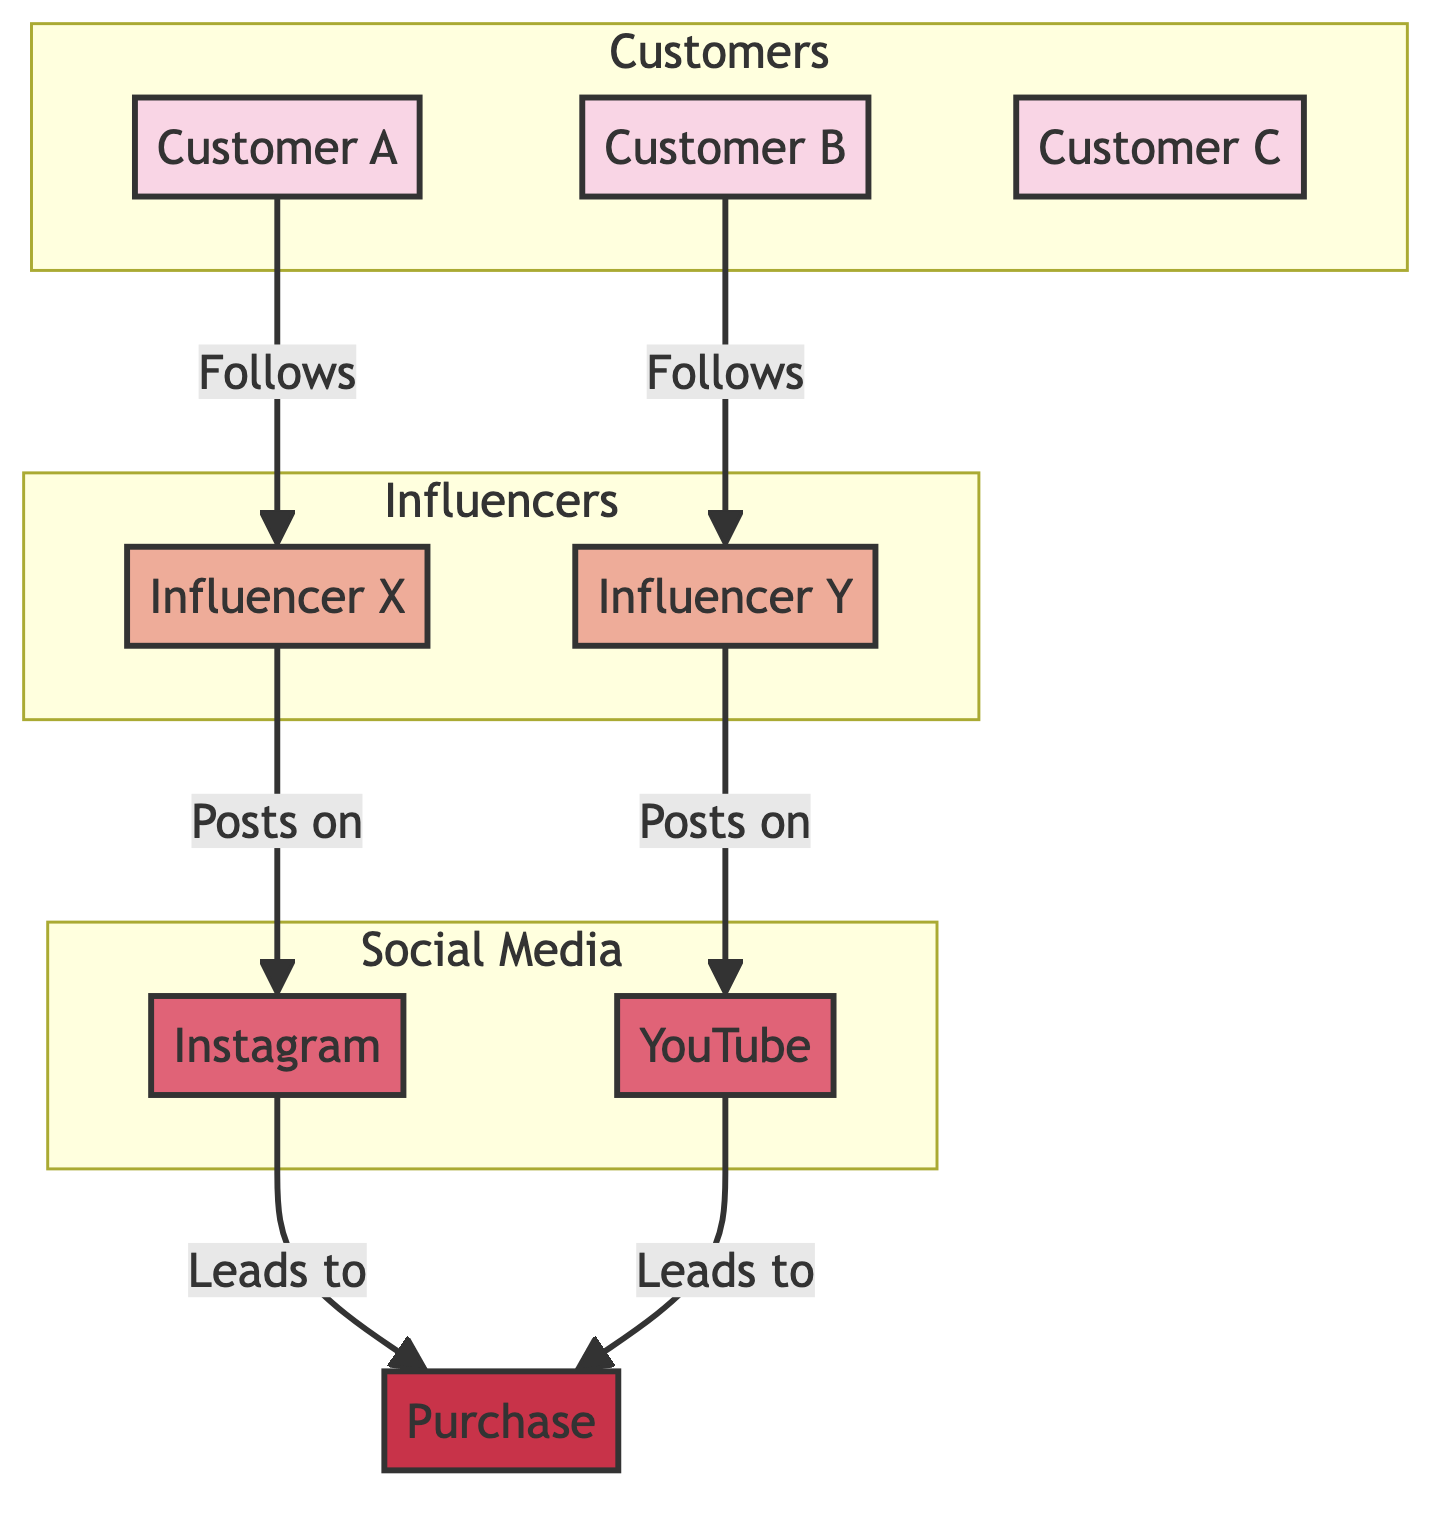What are the names of the influencers showcased in the diagram? The diagram includes Influencer X and Influencer Y as its primary influencers as indicated by the nodes labeled with these names.
Answer: Influencer X, Influencer Y How many customers are represented in the diagram? By counting the customer nodes labeled A, B, and C, we find there are a total of three customers illustrated in the diagram.
Answer: 3 What social media platform leads to purchases from the customers? The diagram shows two social media platforms, Instagram and YouTube, both of which lead to purchases as indicated by the connections labeled with "Leads to Purchase."
Answer: Instagram, YouTube Which customer follows Influencer Y? Customer B is connected to Influencer Y by a line labeled "Follows," thereby establishing the relationship between them.
Answer: Customer B What is the relationship between Customer A and Influencer X? The diagram shows a directional connection from Customer A to Influencer X, marked as "Follows," indicating that Customer A follows Influencer X.
Answer: Follows How many platforms are represented in the diagram? There are two nodes labeled as social media platforms, Instagram and YouTube, which can be counted to conclude the total number of platforms in the diagram.
Answer: 2 Which influencer posts on Instagram? The diagram shows a connection from Influencer X to Instagram, marked with "Posts on," signifying that this influencer is associated with Instagram for posting.
Answer: Influencer X What is the direct outcome of social media interactions in this diagram? The diagram illustrates that both platforms (Instagram and YouTube) directly lead to purchases as indicated by the arrows directing to the purchase node.
Answer: Purchase Which customer does not follow any influencer in the diagram? Customer C is represented in the diagram without any connections to any influencers, which indicates that this specific customer does not follow any.
Answer: Customer C 